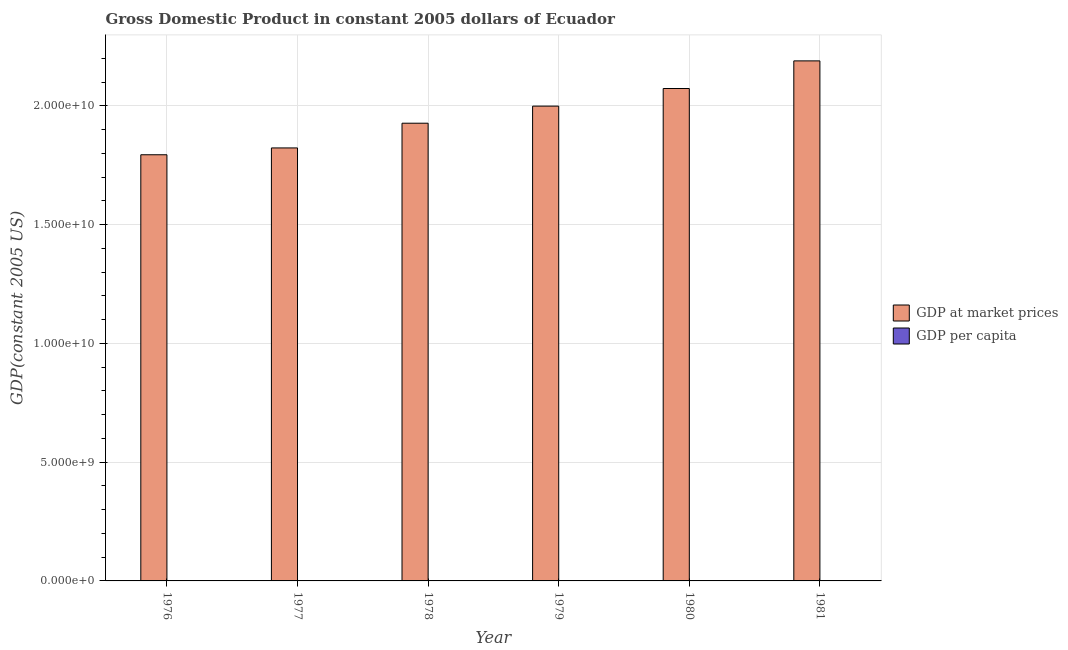How many groups of bars are there?
Make the answer very short. 6. Are the number of bars on each tick of the X-axis equal?
Give a very brief answer. Yes. What is the label of the 3rd group of bars from the left?
Offer a very short reply. 1978. What is the gdp per capita in 1979?
Provide a succinct answer. 2572.33. Across all years, what is the maximum gdp at market prices?
Give a very brief answer. 2.19e+1. Across all years, what is the minimum gdp per capita?
Give a very brief answer. 2472.6. In which year was the gdp at market prices maximum?
Your answer should be compact. 1981. In which year was the gdp at market prices minimum?
Your answer should be very brief. 1976. What is the total gdp per capita in the graph?
Make the answer very short. 1.54e+04. What is the difference between the gdp at market prices in 1977 and that in 1979?
Give a very brief answer. -1.76e+09. What is the difference between the gdp at market prices in 1977 and the gdp per capita in 1980?
Provide a short and direct response. -2.50e+09. What is the average gdp per capita per year?
Ensure brevity in your answer.  2560.94. In the year 1976, what is the difference between the gdp per capita and gdp at market prices?
Provide a short and direct response. 0. What is the ratio of the gdp at market prices in 1979 to that in 1980?
Offer a terse response. 0.96. Is the gdp at market prices in 1977 less than that in 1981?
Offer a terse response. Yes. What is the difference between the highest and the second highest gdp per capita?
Offer a very short reply. 76.55. What is the difference between the highest and the lowest gdp per capita?
Your answer should be very brief. 203.51. In how many years, is the gdp at market prices greater than the average gdp at market prices taken over all years?
Provide a short and direct response. 3. Is the sum of the gdp per capita in 1978 and 1981 greater than the maximum gdp at market prices across all years?
Provide a succinct answer. Yes. What does the 2nd bar from the left in 1976 represents?
Your response must be concise. GDP per capita. What does the 2nd bar from the right in 1978 represents?
Your answer should be very brief. GDP at market prices. How many bars are there?
Offer a very short reply. 12. Does the graph contain grids?
Your answer should be very brief. Yes. Where does the legend appear in the graph?
Make the answer very short. Center right. How are the legend labels stacked?
Make the answer very short. Vertical. What is the title of the graph?
Your answer should be very brief. Gross Domestic Product in constant 2005 dollars of Ecuador. Does "Mobile cellular" appear as one of the legend labels in the graph?
Offer a terse response. No. What is the label or title of the X-axis?
Your answer should be very brief. Year. What is the label or title of the Y-axis?
Your response must be concise. GDP(constant 2005 US). What is the GDP(constant 2005 US) in GDP at market prices in 1976?
Provide a succinct answer. 1.79e+1. What is the GDP(constant 2005 US) in GDP per capita in 1976?
Keep it short and to the point. 2499.59. What is the GDP(constant 2005 US) of GDP at market prices in 1977?
Make the answer very short. 1.82e+1. What is the GDP(constant 2005 US) in GDP per capita in 1977?
Keep it short and to the point. 2472.6. What is the GDP(constant 2005 US) of GDP at market prices in 1978?
Your response must be concise. 1.93e+1. What is the GDP(constant 2005 US) in GDP per capita in 1978?
Your response must be concise. 2545.46. What is the GDP(constant 2005 US) of GDP at market prices in 1979?
Provide a short and direct response. 2.00e+1. What is the GDP(constant 2005 US) of GDP per capita in 1979?
Give a very brief answer. 2572.33. What is the GDP(constant 2005 US) of GDP at market prices in 1980?
Ensure brevity in your answer.  2.07e+1. What is the GDP(constant 2005 US) of GDP per capita in 1980?
Ensure brevity in your answer.  2599.57. What is the GDP(constant 2005 US) of GDP at market prices in 1981?
Offer a terse response. 2.19e+1. What is the GDP(constant 2005 US) in GDP per capita in 1981?
Your response must be concise. 2676.11. Across all years, what is the maximum GDP(constant 2005 US) of GDP at market prices?
Make the answer very short. 2.19e+1. Across all years, what is the maximum GDP(constant 2005 US) of GDP per capita?
Keep it short and to the point. 2676.11. Across all years, what is the minimum GDP(constant 2005 US) of GDP at market prices?
Offer a very short reply. 1.79e+1. Across all years, what is the minimum GDP(constant 2005 US) in GDP per capita?
Provide a short and direct response. 2472.6. What is the total GDP(constant 2005 US) of GDP at market prices in the graph?
Give a very brief answer. 1.18e+11. What is the total GDP(constant 2005 US) in GDP per capita in the graph?
Provide a short and direct response. 1.54e+04. What is the difference between the GDP(constant 2005 US) of GDP at market prices in 1976 and that in 1977?
Make the answer very short. -2.88e+08. What is the difference between the GDP(constant 2005 US) in GDP per capita in 1976 and that in 1977?
Ensure brevity in your answer.  26.99. What is the difference between the GDP(constant 2005 US) of GDP at market prices in 1976 and that in 1978?
Offer a terse response. -1.33e+09. What is the difference between the GDP(constant 2005 US) of GDP per capita in 1976 and that in 1978?
Your answer should be very brief. -45.87. What is the difference between the GDP(constant 2005 US) of GDP at market prices in 1976 and that in 1979?
Offer a very short reply. -2.05e+09. What is the difference between the GDP(constant 2005 US) of GDP per capita in 1976 and that in 1979?
Provide a succinct answer. -72.74. What is the difference between the GDP(constant 2005 US) in GDP at market prices in 1976 and that in 1980?
Give a very brief answer. -2.79e+09. What is the difference between the GDP(constant 2005 US) of GDP per capita in 1976 and that in 1980?
Your answer should be very brief. -99.98. What is the difference between the GDP(constant 2005 US) of GDP at market prices in 1976 and that in 1981?
Your response must be concise. -3.95e+09. What is the difference between the GDP(constant 2005 US) of GDP per capita in 1976 and that in 1981?
Offer a very short reply. -176.52. What is the difference between the GDP(constant 2005 US) in GDP at market prices in 1977 and that in 1978?
Your answer should be very brief. -1.04e+09. What is the difference between the GDP(constant 2005 US) in GDP per capita in 1977 and that in 1978?
Provide a short and direct response. -72.86. What is the difference between the GDP(constant 2005 US) of GDP at market prices in 1977 and that in 1979?
Provide a short and direct response. -1.76e+09. What is the difference between the GDP(constant 2005 US) of GDP per capita in 1977 and that in 1979?
Your response must be concise. -99.73. What is the difference between the GDP(constant 2005 US) in GDP at market prices in 1977 and that in 1980?
Offer a very short reply. -2.50e+09. What is the difference between the GDP(constant 2005 US) in GDP per capita in 1977 and that in 1980?
Make the answer very short. -126.97. What is the difference between the GDP(constant 2005 US) of GDP at market prices in 1977 and that in 1981?
Make the answer very short. -3.67e+09. What is the difference between the GDP(constant 2005 US) of GDP per capita in 1977 and that in 1981?
Ensure brevity in your answer.  -203.51. What is the difference between the GDP(constant 2005 US) in GDP at market prices in 1978 and that in 1979?
Ensure brevity in your answer.  -7.20e+08. What is the difference between the GDP(constant 2005 US) in GDP per capita in 1978 and that in 1979?
Make the answer very short. -26.87. What is the difference between the GDP(constant 2005 US) of GDP at market prices in 1978 and that in 1980?
Make the answer very short. -1.46e+09. What is the difference between the GDP(constant 2005 US) in GDP per capita in 1978 and that in 1980?
Your response must be concise. -54.11. What is the difference between the GDP(constant 2005 US) of GDP at market prices in 1978 and that in 1981?
Provide a short and direct response. -2.63e+09. What is the difference between the GDP(constant 2005 US) of GDP per capita in 1978 and that in 1981?
Ensure brevity in your answer.  -130.65. What is the difference between the GDP(constant 2005 US) in GDP at market prices in 1979 and that in 1980?
Ensure brevity in your answer.  -7.42e+08. What is the difference between the GDP(constant 2005 US) in GDP per capita in 1979 and that in 1980?
Offer a very short reply. -27.24. What is the difference between the GDP(constant 2005 US) in GDP at market prices in 1979 and that in 1981?
Offer a terse response. -1.91e+09. What is the difference between the GDP(constant 2005 US) in GDP per capita in 1979 and that in 1981?
Give a very brief answer. -103.79. What is the difference between the GDP(constant 2005 US) of GDP at market prices in 1980 and that in 1981?
Your response must be concise. -1.16e+09. What is the difference between the GDP(constant 2005 US) in GDP per capita in 1980 and that in 1981?
Give a very brief answer. -76.55. What is the difference between the GDP(constant 2005 US) of GDP at market prices in 1976 and the GDP(constant 2005 US) of GDP per capita in 1977?
Your response must be concise. 1.79e+1. What is the difference between the GDP(constant 2005 US) of GDP at market prices in 1976 and the GDP(constant 2005 US) of GDP per capita in 1978?
Offer a very short reply. 1.79e+1. What is the difference between the GDP(constant 2005 US) in GDP at market prices in 1976 and the GDP(constant 2005 US) in GDP per capita in 1979?
Ensure brevity in your answer.  1.79e+1. What is the difference between the GDP(constant 2005 US) in GDP at market prices in 1976 and the GDP(constant 2005 US) in GDP per capita in 1980?
Offer a very short reply. 1.79e+1. What is the difference between the GDP(constant 2005 US) in GDP at market prices in 1976 and the GDP(constant 2005 US) in GDP per capita in 1981?
Give a very brief answer. 1.79e+1. What is the difference between the GDP(constant 2005 US) of GDP at market prices in 1977 and the GDP(constant 2005 US) of GDP per capita in 1978?
Make the answer very short. 1.82e+1. What is the difference between the GDP(constant 2005 US) in GDP at market prices in 1977 and the GDP(constant 2005 US) in GDP per capita in 1979?
Your answer should be very brief. 1.82e+1. What is the difference between the GDP(constant 2005 US) of GDP at market prices in 1977 and the GDP(constant 2005 US) of GDP per capita in 1980?
Give a very brief answer. 1.82e+1. What is the difference between the GDP(constant 2005 US) in GDP at market prices in 1977 and the GDP(constant 2005 US) in GDP per capita in 1981?
Provide a short and direct response. 1.82e+1. What is the difference between the GDP(constant 2005 US) in GDP at market prices in 1978 and the GDP(constant 2005 US) in GDP per capita in 1979?
Provide a succinct answer. 1.93e+1. What is the difference between the GDP(constant 2005 US) of GDP at market prices in 1978 and the GDP(constant 2005 US) of GDP per capita in 1980?
Provide a short and direct response. 1.93e+1. What is the difference between the GDP(constant 2005 US) in GDP at market prices in 1978 and the GDP(constant 2005 US) in GDP per capita in 1981?
Ensure brevity in your answer.  1.93e+1. What is the difference between the GDP(constant 2005 US) in GDP at market prices in 1979 and the GDP(constant 2005 US) in GDP per capita in 1980?
Offer a very short reply. 2.00e+1. What is the difference between the GDP(constant 2005 US) of GDP at market prices in 1979 and the GDP(constant 2005 US) of GDP per capita in 1981?
Provide a short and direct response. 2.00e+1. What is the difference between the GDP(constant 2005 US) of GDP at market prices in 1980 and the GDP(constant 2005 US) of GDP per capita in 1981?
Make the answer very short. 2.07e+1. What is the average GDP(constant 2005 US) in GDP at market prices per year?
Offer a terse response. 1.97e+1. What is the average GDP(constant 2005 US) in GDP per capita per year?
Your answer should be very brief. 2560.94. In the year 1976, what is the difference between the GDP(constant 2005 US) in GDP at market prices and GDP(constant 2005 US) in GDP per capita?
Your answer should be compact. 1.79e+1. In the year 1977, what is the difference between the GDP(constant 2005 US) of GDP at market prices and GDP(constant 2005 US) of GDP per capita?
Give a very brief answer. 1.82e+1. In the year 1978, what is the difference between the GDP(constant 2005 US) of GDP at market prices and GDP(constant 2005 US) of GDP per capita?
Give a very brief answer. 1.93e+1. In the year 1979, what is the difference between the GDP(constant 2005 US) in GDP at market prices and GDP(constant 2005 US) in GDP per capita?
Provide a short and direct response. 2.00e+1. In the year 1980, what is the difference between the GDP(constant 2005 US) of GDP at market prices and GDP(constant 2005 US) of GDP per capita?
Keep it short and to the point. 2.07e+1. In the year 1981, what is the difference between the GDP(constant 2005 US) in GDP at market prices and GDP(constant 2005 US) in GDP per capita?
Your response must be concise. 2.19e+1. What is the ratio of the GDP(constant 2005 US) in GDP at market prices in 1976 to that in 1977?
Provide a short and direct response. 0.98. What is the ratio of the GDP(constant 2005 US) of GDP per capita in 1976 to that in 1977?
Ensure brevity in your answer.  1.01. What is the ratio of the GDP(constant 2005 US) of GDP at market prices in 1976 to that in 1978?
Make the answer very short. 0.93. What is the ratio of the GDP(constant 2005 US) of GDP per capita in 1976 to that in 1978?
Give a very brief answer. 0.98. What is the ratio of the GDP(constant 2005 US) in GDP at market prices in 1976 to that in 1979?
Offer a very short reply. 0.9. What is the ratio of the GDP(constant 2005 US) in GDP per capita in 1976 to that in 1979?
Offer a very short reply. 0.97. What is the ratio of the GDP(constant 2005 US) of GDP at market prices in 1976 to that in 1980?
Give a very brief answer. 0.87. What is the ratio of the GDP(constant 2005 US) of GDP per capita in 1976 to that in 1980?
Offer a terse response. 0.96. What is the ratio of the GDP(constant 2005 US) of GDP at market prices in 1976 to that in 1981?
Make the answer very short. 0.82. What is the ratio of the GDP(constant 2005 US) in GDP per capita in 1976 to that in 1981?
Provide a succinct answer. 0.93. What is the ratio of the GDP(constant 2005 US) of GDP at market prices in 1977 to that in 1978?
Make the answer very short. 0.95. What is the ratio of the GDP(constant 2005 US) of GDP per capita in 1977 to that in 1978?
Your response must be concise. 0.97. What is the ratio of the GDP(constant 2005 US) of GDP at market prices in 1977 to that in 1979?
Your response must be concise. 0.91. What is the ratio of the GDP(constant 2005 US) of GDP per capita in 1977 to that in 1979?
Offer a terse response. 0.96. What is the ratio of the GDP(constant 2005 US) of GDP at market prices in 1977 to that in 1980?
Your answer should be very brief. 0.88. What is the ratio of the GDP(constant 2005 US) of GDP per capita in 1977 to that in 1980?
Offer a very short reply. 0.95. What is the ratio of the GDP(constant 2005 US) of GDP at market prices in 1977 to that in 1981?
Make the answer very short. 0.83. What is the ratio of the GDP(constant 2005 US) of GDP per capita in 1977 to that in 1981?
Offer a very short reply. 0.92. What is the ratio of the GDP(constant 2005 US) of GDP per capita in 1978 to that in 1979?
Offer a terse response. 0.99. What is the ratio of the GDP(constant 2005 US) in GDP at market prices in 1978 to that in 1980?
Your answer should be very brief. 0.93. What is the ratio of the GDP(constant 2005 US) of GDP per capita in 1978 to that in 1980?
Offer a very short reply. 0.98. What is the ratio of the GDP(constant 2005 US) of GDP at market prices in 1978 to that in 1981?
Give a very brief answer. 0.88. What is the ratio of the GDP(constant 2005 US) of GDP per capita in 1978 to that in 1981?
Your response must be concise. 0.95. What is the ratio of the GDP(constant 2005 US) in GDP at market prices in 1979 to that in 1980?
Your answer should be compact. 0.96. What is the ratio of the GDP(constant 2005 US) in GDP per capita in 1979 to that in 1980?
Give a very brief answer. 0.99. What is the ratio of the GDP(constant 2005 US) in GDP per capita in 1979 to that in 1981?
Give a very brief answer. 0.96. What is the ratio of the GDP(constant 2005 US) of GDP at market prices in 1980 to that in 1981?
Your answer should be very brief. 0.95. What is the ratio of the GDP(constant 2005 US) in GDP per capita in 1980 to that in 1981?
Make the answer very short. 0.97. What is the difference between the highest and the second highest GDP(constant 2005 US) in GDP at market prices?
Provide a short and direct response. 1.16e+09. What is the difference between the highest and the second highest GDP(constant 2005 US) of GDP per capita?
Offer a very short reply. 76.55. What is the difference between the highest and the lowest GDP(constant 2005 US) of GDP at market prices?
Provide a succinct answer. 3.95e+09. What is the difference between the highest and the lowest GDP(constant 2005 US) of GDP per capita?
Your answer should be very brief. 203.51. 